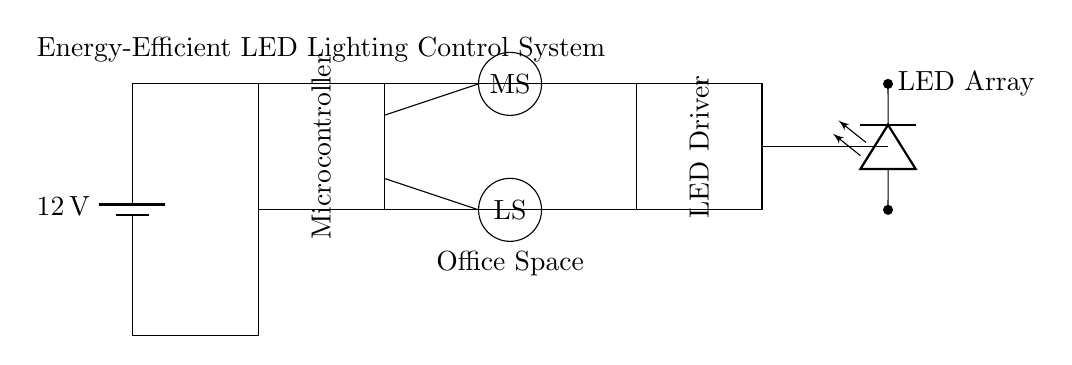what is the voltage of this circuit? The voltage is 12 volts, which comes from the battery as indicated in the diagram.
Answer: 12 volts what are the primary components in the circuit? The primary components are a microcontroller, motion sensor, light sensor, LED driver, and LED array, all of which are shown clearly in the circuit diagram.
Answer: Microcontroller, motion sensor, light sensor, LED driver, LED array what is the purpose of the motion sensor? The purpose of the motion sensor is to detect movement within the office space and signal the microcontroller to control the lighting accordingly.
Answer: Detect movement how does the light sensor affect the LED driver? The light sensor measures ambient light levels and communicates this information to the microcontroller, which then adjusts the output of the LED driver to maintain desired lighting conditions.
Answer: Adjusts lighting conditions what type of system does this circuit represent? This circuit represents an energy-efficient lighting control system designed specifically for office spaces to manage lighting based on occupancy and natural light levels.
Answer: Energy-efficient lighting control system what role does the microcontroller play in the circuit? The microcontroller acts as the brain of the system, processing the input from the sensors (motion and light) and controlling the LED driver to manage the LED array based on the detected conditions.
Answer: Controls the system functions 